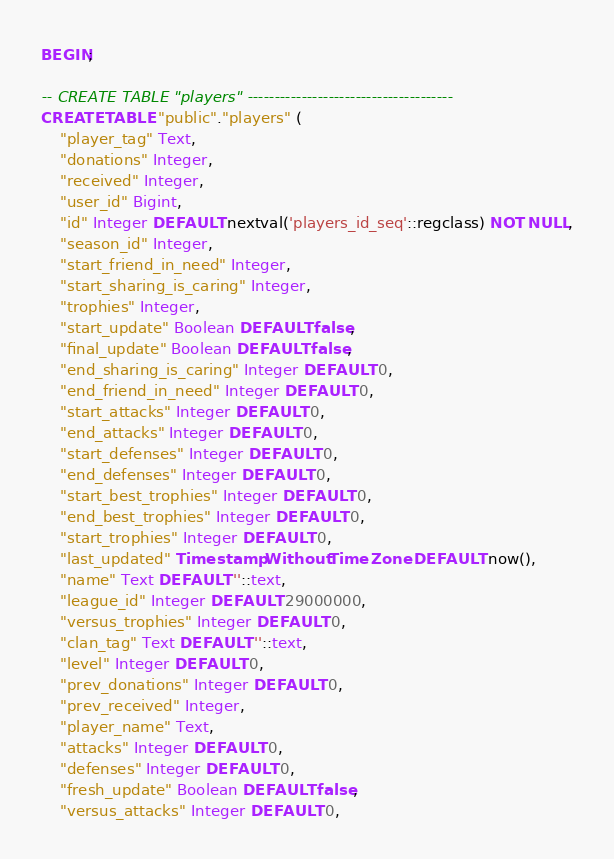Convert code to text. <code><loc_0><loc_0><loc_500><loc_500><_SQL_>BEGIN;

-- CREATE TABLE "players" --------------------------------------
CREATE TABLE "public"."players" (
	"player_tag" Text,
	"donations" Integer,
	"received" Integer,
	"user_id" Bigint,
	"id" Integer DEFAULT nextval('players_id_seq'::regclass) NOT NULL,
	"season_id" Integer,
	"start_friend_in_need" Integer,
	"start_sharing_is_caring" Integer,
	"trophies" Integer,
	"start_update" Boolean DEFAULT false,
	"final_update" Boolean DEFAULT false,
	"end_sharing_is_caring" Integer DEFAULT 0,
	"end_friend_in_need" Integer DEFAULT 0,
	"start_attacks" Integer DEFAULT 0,
	"end_attacks" Integer DEFAULT 0,
	"start_defenses" Integer DEFAULT 0,
	"end_defenses" Integer DEFAULT 0,
	"start_best_trophies" Integer DEFAULT 0,
	"end_best_trophies" Integer DEFAULT 0,
	"start_trophies" Integer DEFAULT 0,
	"last_updated" Timestamp Without Time Zone DEFAULT now(),
	"name" Text DEFAULT ''::text,
	"league_id" Integer DEFAULT 29000000,
	"versus_trophies" Integer DEFAULT 0,
	"clan_tag" Text DEFAULT ''::text,
	"level" Integer DEFAULT 0,
	"prev_donations" Integer DEFAULT 0,
	"prev_received" Integer,
	"player_name" Text,
	"attacks" Integer DEFAULT 0,
	"defenses" Integer DEFAULT 0,
	"fresh_update" Boolean DEFAULT false,
	"versus_attacks" Integer DEFAULT 0,</code> 